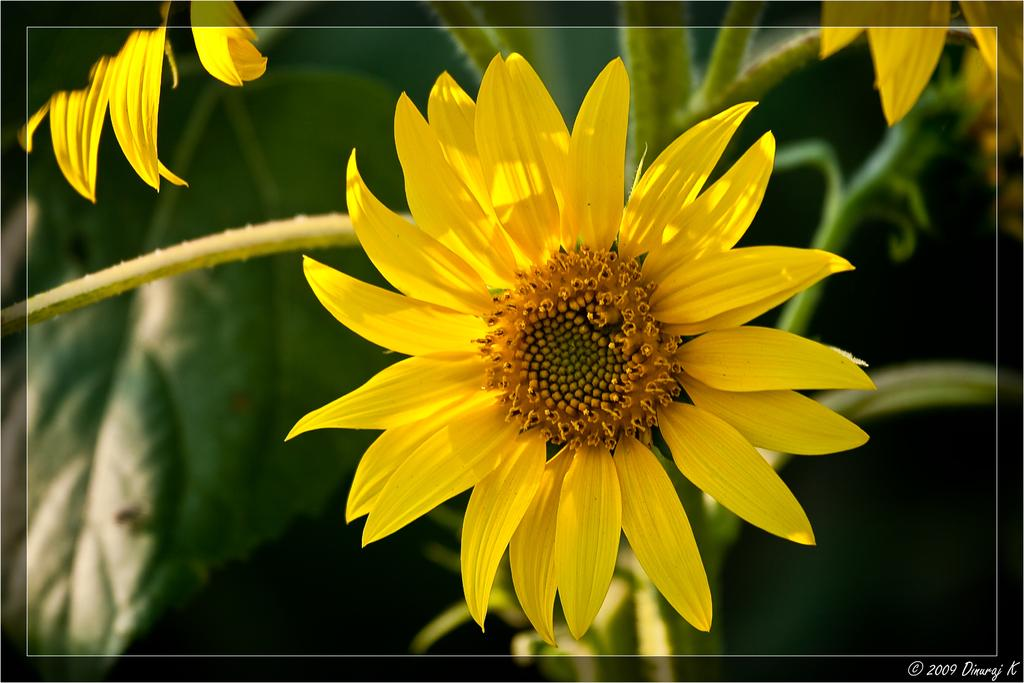What type of plant elements can be seen in the image? The image contains flowers, leaves, and stems. How is the background of the image depicted? The background of the image is blurred. Is there any text present in the image? Yes, there is text in the bottom right corner of the image. How many snails can be seen crawling on the flowers in the image? There are no snails present in the image; it only contains flowers, leaves, and stems. What color is the robin perched on the balloon in the image? There is no robin or balloon present in the image. 